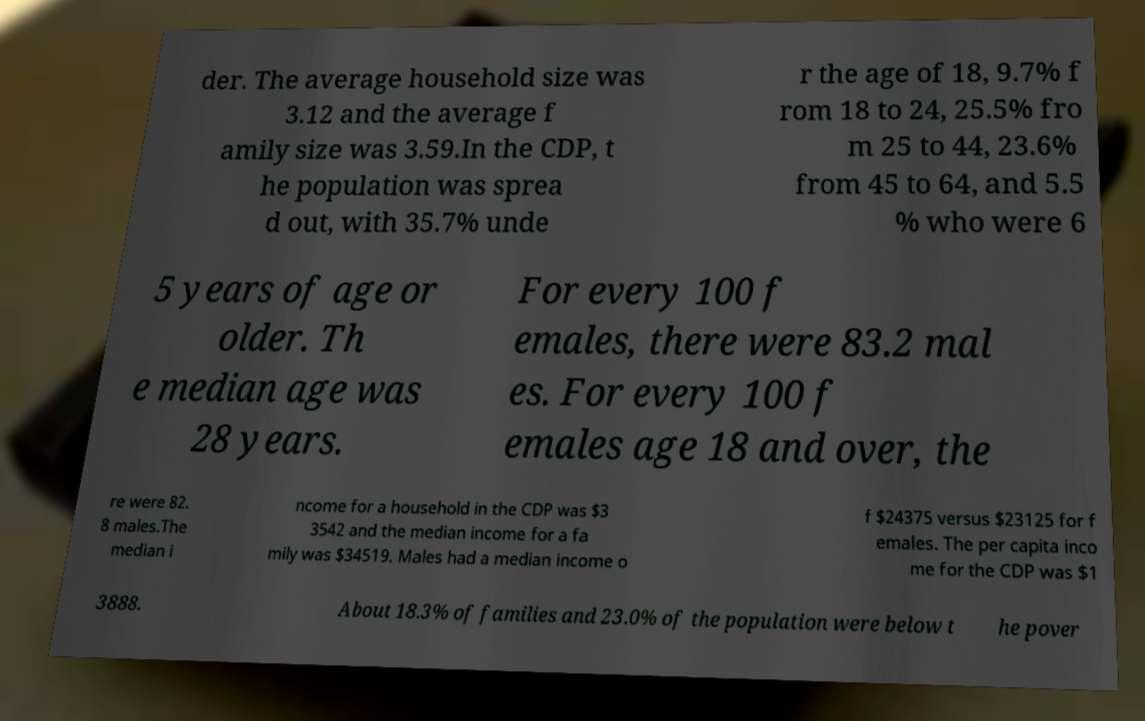I need the written content from this picture converted into text. Can you do that? der. The average household size was 3.12 and the average f amily size was 3.59.In the CDP, t he population was sprea d out, with 35.7% unde r the age of 18, 9.7% f rom 18 to 24, 25.5% fro m 25 to 44, 23.6% from 45 to 64, and 5.5 % who were 6 5 years of age or older. Th e median age was 28 years. For every 100 f emales, there were 83.2 mal es. For every 100 f emales age 18 and over, the re were 82. 8 males.The median i ncome for a household in the CDP was $3 3542 and the median income for a fa mily was $34519. Males had a median income o f $24375 versus $23125 for f emales. The per capita inco me for the CDP was $1 3888. About 18.3% of families and 23.0% of the population were below t he pover 